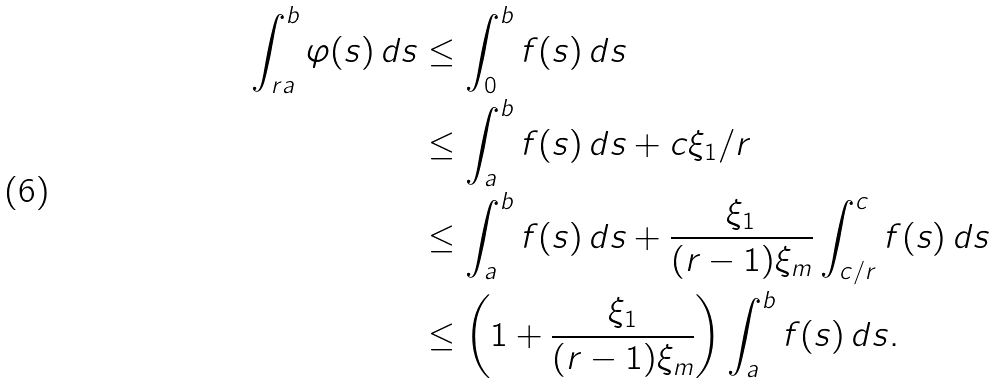<formula> <loc_0><loc_0><loc_500><loc_500>\int _ { r a } ^ { b } \varphi ( s ) \, d s & \leq \int _ { 0 } ^ { b } f ( s ) \, d s \\ & \leq \int _ { a } ^ { b } f ( s ) \, d s + c \xi _ { 1 } / r \\ & \leq \int _ { a } ^ { b } f ( s ) \, d s + \frac { \xi _ { 1 } } { ( r - 1 ) \xi _ { m } } \int _ { c / r } ^ { c } f ( s ) \, d s \\ & \leq \left ( 1 + \frac { \xi _ { 1 } } { ( r - 1 ) \xi _ { m } } \right ) \int _ { a } ^ { b } f ( s ) \, d s .</formula> 